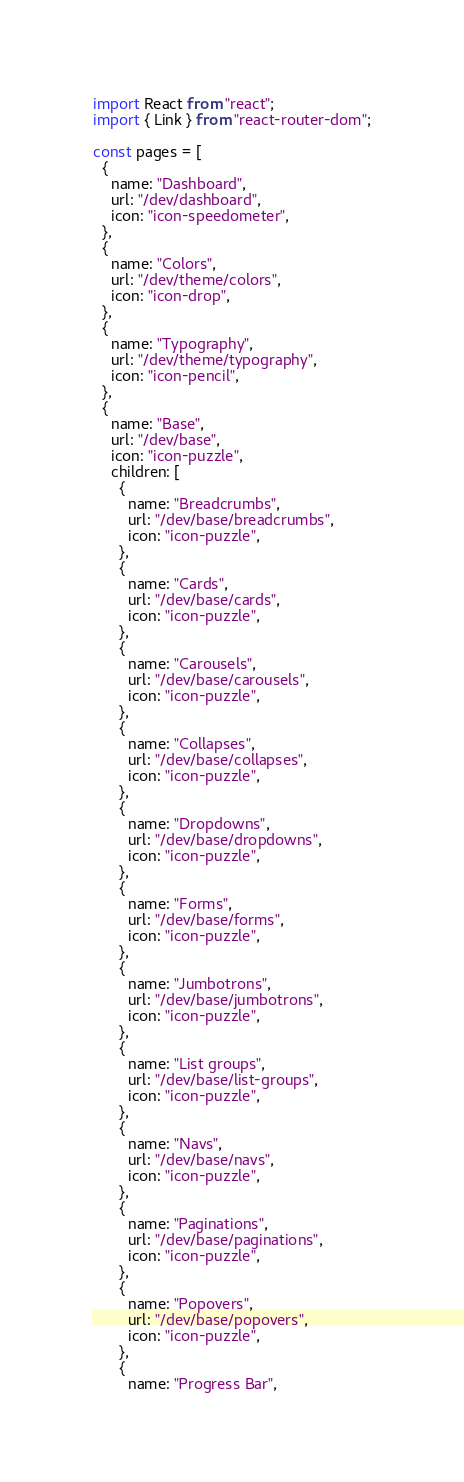Convert code to text. <code><loc_0><loc_0><loc_500><loc_500><_JavaScript_>import React from "react";
import { Link } from "react-router-dom";

const pages = [
  {
    name: "Dashboard",
    url: "/dev/dashboard",
    icon: "icon-speedometer",
  },
  {
    name: "Colors",
    url: "/dev/theme/colors",
    icon: "icon-drop",
  },
  {
    name: "Typography",
    url: "/dev/theme/typography",
    icon: "icon-pencil",
  },
  {
    name: "Base",
    url: "/dev/base",
    icon: "icon-puzzle",
    children: [
      {
        name: "Breadcrumbs",
        url: "/dev/base/breadcrumbs",
        icon: "icon-puzzle",
      },
      {
        name: "Cards",
        url: "/dev/base/cards",
        icon: "icon-puzzle",
      },
      {
        name: "Carousels",
        url: "/dev/base/carousels",
        icon: "icon-puzzle",
      },
      {
        name: "Collapses",
        url: "/dev/base/collapses",
        icon: "icon-puzzle",
      },
      {
        name: "Dropdowns",
        url: "/dev/base/dropdowns",
        icon: "icon-puzzle",
      },
      {
        name: "Forms",
        url: "/dev/base/forms",
        icon: "icon-puzzle",
      },
      {
        name: "Jumbotrons",
        url: "/dev/base/jumbotrons",
        icon: "icon-puzzle",
      },
      {
        name: "List groups",
        url: "/dev/base/list-groups",
        icon: "icon-puzzle",
      },
      {
        name: "Navs",
        url: "/dev/base/navs",
        icon: "icon-puzzle",
      },
      {
        name: "Paginations",
        url: "/dev/base/paginations",
        icon: "icon-puzzle",
      },
      {
        name: "Popovers",
        url: "/dev/base/popovers",
        icon: "icon-puzzle",
      },
      {
        name: "Progress Bar",</code> 